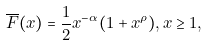<formula> <loc_0><loc_0><loc_500><loc_500>\overline { F } ( x ) & = \frac { 1 } { 2 } x ^ { - \alpha } ( 1 + x ^ { \rho } ) , x \geq 1 ,</formula> 